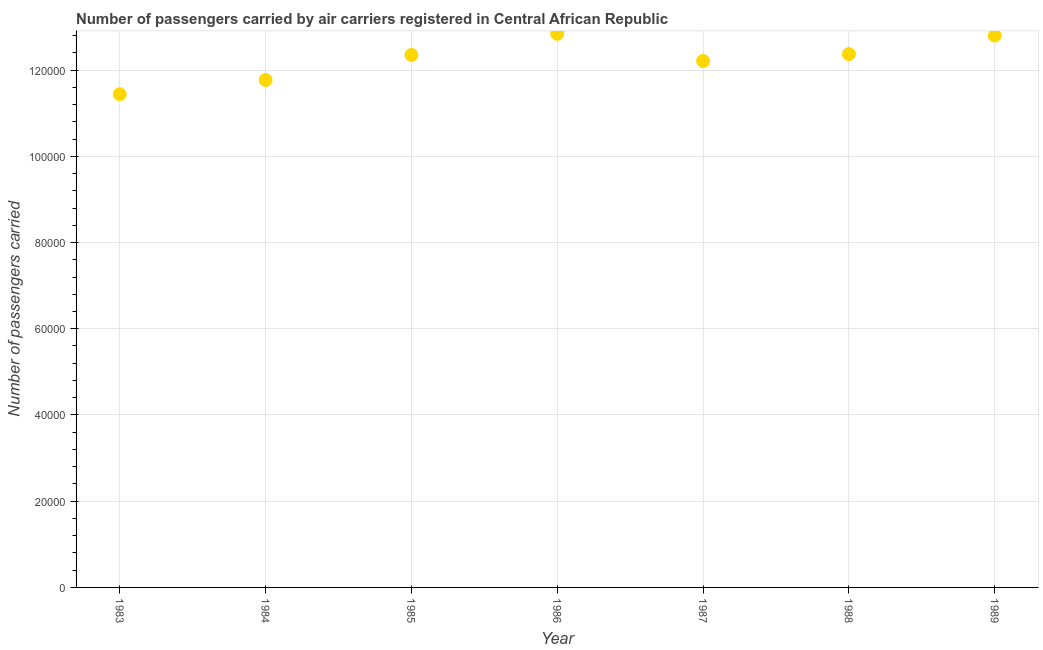What is the number of passengers carried in 1988?
Offer a very short reply. 1.24e+05. Across all years, what is the maximum number of passengers carried?
Make the answer very short. 1.28e+05. Across all years, what is the minimum number of passengers carried?
Your response must be concise. 1.14e+05. What is the sum of the number of passengers carried?
Your response must be concise. 8.58e+05. What is the difference between the number of passengers carried in 1983 and 1986?
Keep it short and to the point. -1.40e+04. What is the average number of passengers carried per year?
Keep it short and to the point. 1.23e+05. What is the median number of passengers carried?
Make the answer very short. 1.24e+05. In how many years, is the number of passengers carried greater than 32000 ?
Offer a very short reply. 7. Do a majority of the years between 1988 and 1989 (inclusive) have number of passengers carried greater than 28000 ?
Your response must be concise. Yes. What is the ratio of the number of passengers carried in 1983 to that in 1986?
Your answer should be very brief. 0.89. What is the difference between the highest and the lowest number of passengers carried?
Offer a terse response. 1.40e+04. In how many years, is the number of passengers carried greater than the average number of passengers carried taken over all years?
Make the answer very short. 4. Does the number of passengers carried monotonically increase over the years?
Keep it short and to the point. No. How many dotlines are there?
Provide a short and direct response. 1. How many years are there in the graph?
Ensure brevity in your answer.  7. What is the difference between two consecutive major ticks on the Y-axis?
Your answer should be very brief. 2.00e+04. Are the values on the major ticks of Y-axis written in scientific E-notation?
Offer a terse response. No. What is the title of the graph?
Provide a succinct answer. Number of passengers carried by air carriers registered in Central African Republic. What is the label or title of the Y-axis?
Ensure brevity in your answer.  Number of passengers carried. What is the Number of passengers carried in 1983?
Give a very brief answer. 1.14e+05. What is the Number of passengers carried in 1984?
Your answer should be compact. 1.18e+05. What is the Number of passengers carried in 1985?
Your response must be concise. 1.24e+05. What is the Number of passengers carried in 1986?
Offer a terse response. 1.28e+05. What is the Number of passengers carried in 1987?
Make the answer very short. 1.22e+05. What is the Number of passengers carried in 1988?
Give a very brief answer. 1.24e+05. What is the Number of passengers carried in 1989?
Your answer should be very brief. 1.28e+05. What is the difference between the Number of passengers carried in 1983 and 1984?
Provide a succinct answer. -3300. What is the difference between the Number of passengers carried in 1983 and 1985?
Your answer should be very brief. -9100. What is the difference between the Number of passengers carried in 1983 and 1986?
Ensure brevity in your answer.  -1.40e+04. What is the difference between the Number of passengers carried in 1983 and 1987?
Your answer should be very brief. -7700. What is the difference between the Number of passengers carried in 1983 and 1988?
Your answer should be very brief. -9300. What is the difference between the Number of passengers carried in 1983 and 1989?
Keep it short and to the point. -1.36e+04. What is the difference between the Number of passengers carried in 1984 and 1985?
Your answer should be compact. -5800. What is the difference between the Number of passengers carried in 1984 and 1986?
Your answer should be very brief. -1.07e+04. What is the difference between the Number of passengers carried in 1984 and 1987?
Ensure brevity in your answer.  -4400. What is the difference between the Number of passengers carried in 1984 and 1988?
Make the answer very short. -6000. What is the difference between the Number of passengers carried in 1984 and 1989?
Provide a succinct answer. -1.03e+04. What is the difference between the Number of passengers carried in 1985 and 1986?
Offer a terse response. -4900. What is the difference between the Number of passengers carried in 1985 and 1987?
Keep it short and to the point. 1400. What is the difference between the Number of passengers carried in 1985 and 1988?
Provide a succinct answer. -200. What is the difference between the Number of passengers carried in 1985 and 1989?
Keep it short and to the point. -4500. What is the difference between the Number of passengers carried in 1986 and 1987?
Offer a very short reply. 6300. What is the difference between the Number of passengers carried in 1986 and 1988?
Keep it short and to the point. 4700. What is the difference between the Number of passengers carried in 1986 and 1989?
Your answer should be compact. 400. What is the difference between the Number of passengers carried in 1987 and 1988?
Your answer should be very brief. -1600. What is the difference between the Number of passengers carried in 1987 and 1989?
Offer a very short reply. -5900. What is the difference between the Number of passengers carried in 1988 and 1989?
Give a very brief answer. -4300. What is the ratio of the Number of passengers carried in 1983 to that in 1984?
Ensure brevity in your answer.  0.97. What is the ratio of the Number of passengers carried in 1983 to that in 1985?
Your answer should be very brief. 0.93. What is the ratio of the Number of passengers carried in 1983 to that in 1986?
Your answer should be compact. 0.89. What is the ratio of the Number of passengers carried in 1983 to that in 1987?
Offer a very short reply. 0.94. What is the ratio of the Number of passengers carried in 1983 to that in 1988?
Give a very brief answer. 0.93. What is the ratio of the Number of passengers carried in 1983 to that in 1989?
Your response must be concise. 0.89. What is the ratio of the Number of passengers carried in 1984 to that in 1985?
Give a very brief answer. 0.95. What is the ratio of the Number of passengers carried in 1984 to that in 1986?
Ensure brevity in your answer.  0.92. What is the ratio of the Number of passengers carried in 1984 to that in 1987?
Keep it short and to the point. 0.96. What is the ratio of the Number of passengers carried in 1984 to that in 1988?
Give a very brief answer. 0.95. What is the ratio of the Number of passengers carried in 1984 to that in 1989?
Offer a very short reply. 0.92. What is the ratio of the Number of passengers carried in 1985 to that in 1987?
Your response must be concise. 1.01. What is the ratio of the Number of passengers carried in 1986 to that in 1987?
Your response must be concise. 1.05. What is the ratio of the Number of passengers carried in 1986 to that in 1988?
Make the answer very short. 1.04. What is the ratio of the Number of passengers carried in 1986 to that in 1989?
Offer a very short reply. 1. What is the ratio of the Number of passengers carried in 1987 to that in 1989?
Provide a succinct answer. 0.95. What is the ratio of the Number of passengers carried in 1988 to that in 1989?
Offer a terse response. 0.97. 